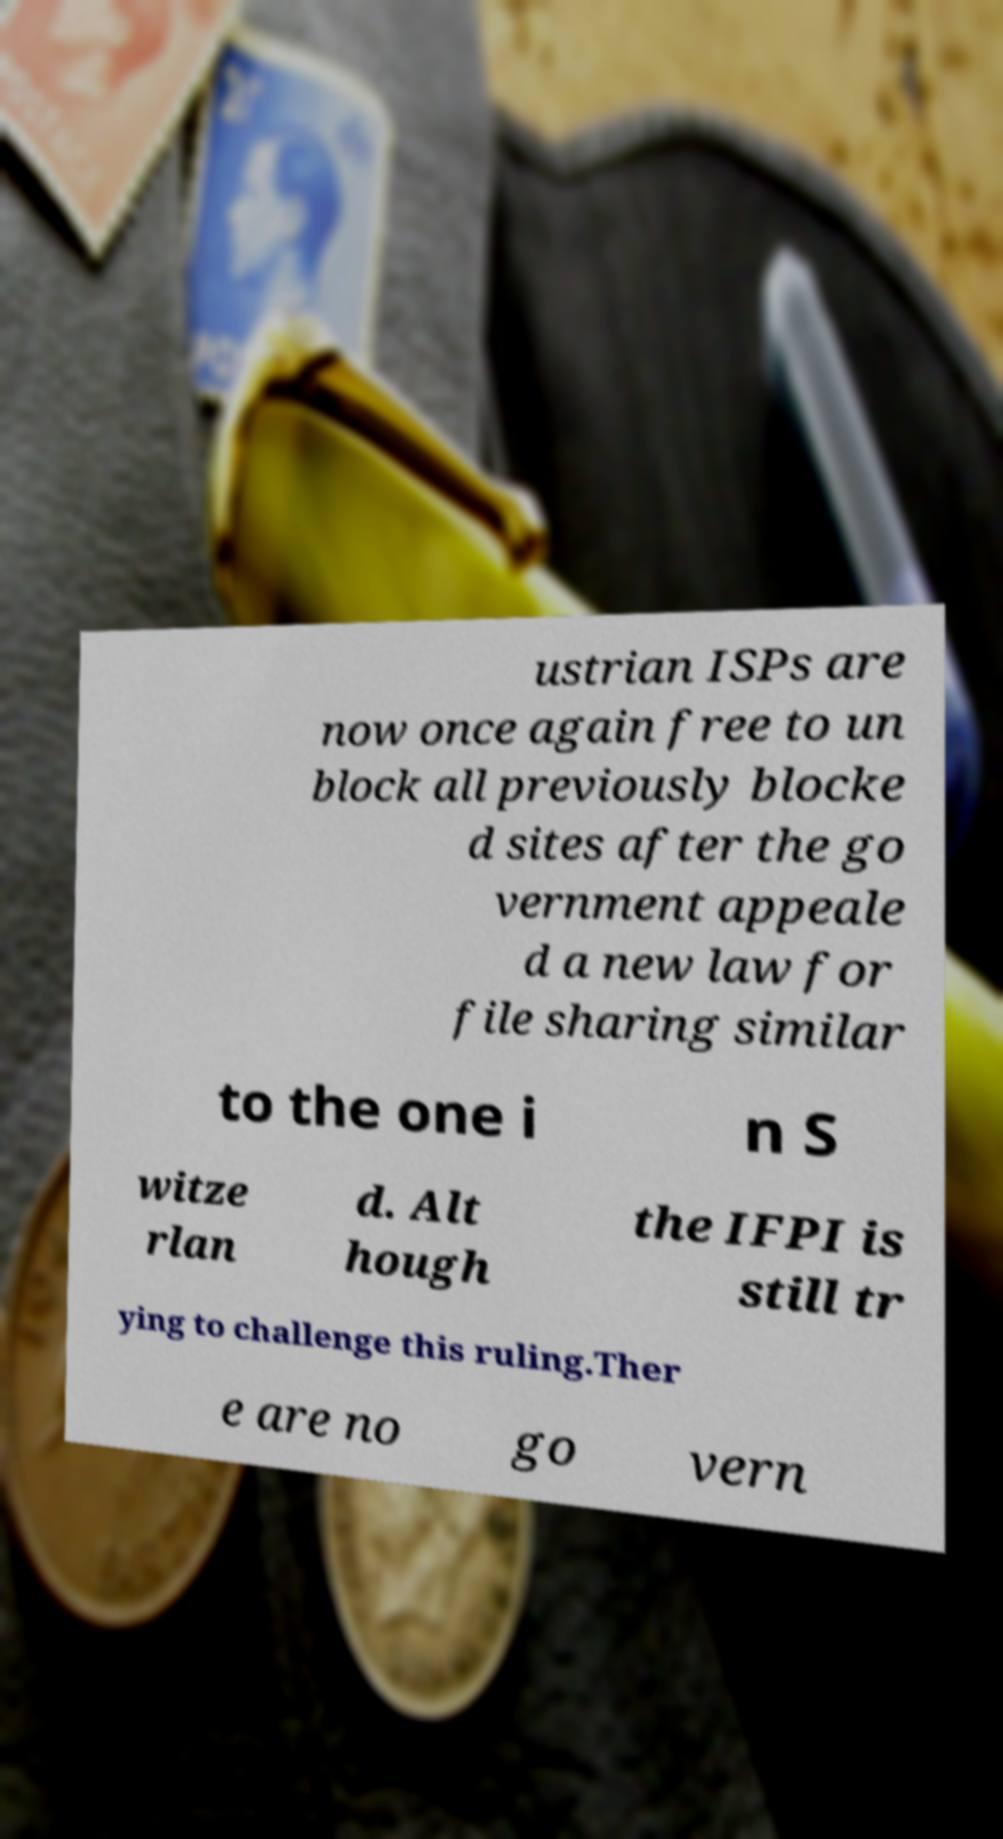Please read and relay the text visible in this image. What does it say? ustrian ISPs are now once again free to un block all previously blocke d sites after the go vernment appeale d a new law for file sharing similar to the one i n S witze rlan d. Alt hough the IFPI is still tr ying to challenge this ruling.Ther e are no go vern 